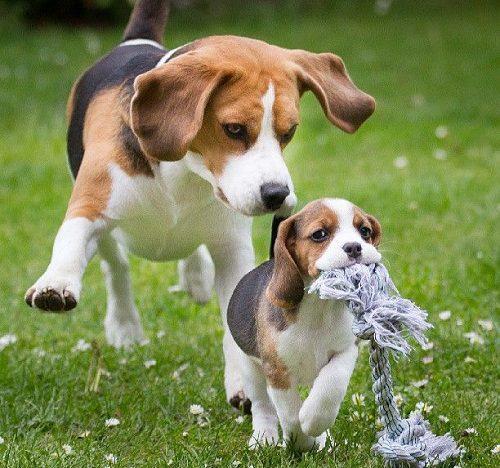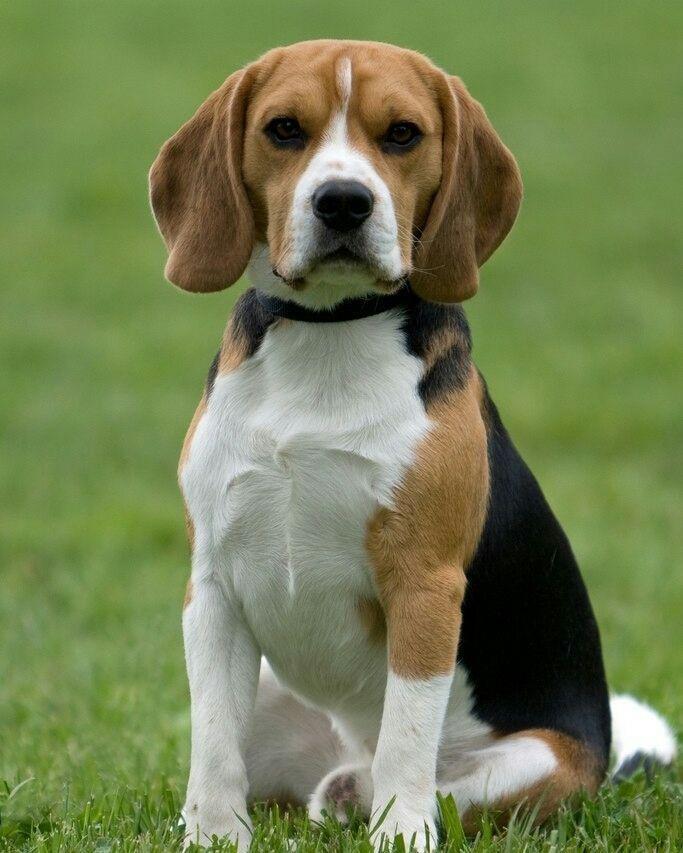The first image is the image on the left, the second image is the image on the right. Assess this claim about the two images: "At least one dog has its mouth open.". Correct or not? Answer yes or no. No. 